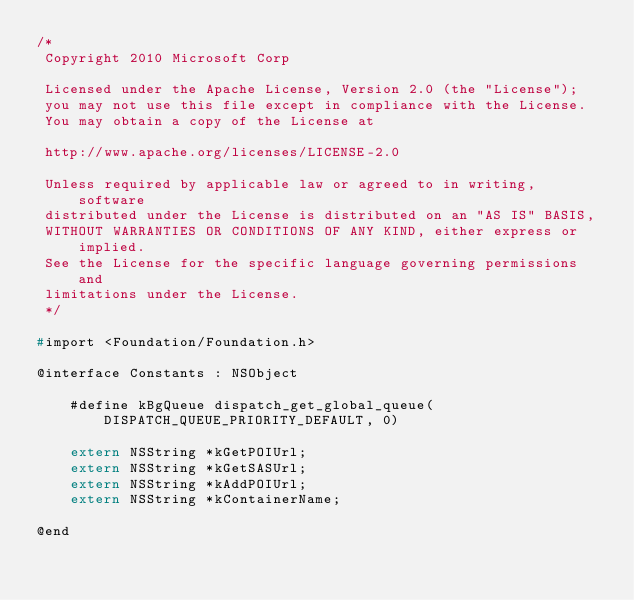<code> <loc_0><loc_0><loc_500><loc_500><_C_>/*
 Copyright 2010 Microsoft Corp
 
 Licensed under the Apache License, Version 2.0 (the "License");
 you may not use this file except in compliance with the License.
 You may obtain a copy of the License at
 
 http://www.apache.org/licenses/LICENSE-2.0
 
 Unless required by applicable law or agreed to in writing, software
 distributed under the License is distributed on an "AS IS" BASIS,
 WITHOUT WARRANTIES OR CONDITIONS OF ANY KIND, either express or implied.
 See the License for the specific language governing permissions and
 limitations under the License.
 */

#import <Foundation/Foundation.h>

@interface Constants : NSObject

    #define kBgQueue dispatch_get_global_queue(DISPATCH_QUEUE_PRIORITY_DEFAULT, 0)

    extern NSString *kGetPOIUrl;
    extern NSString *kGetSASUrl;
    extern NSString *kAddPOIUrl;
    extern NSString *kContainerName;

@end
</code> 